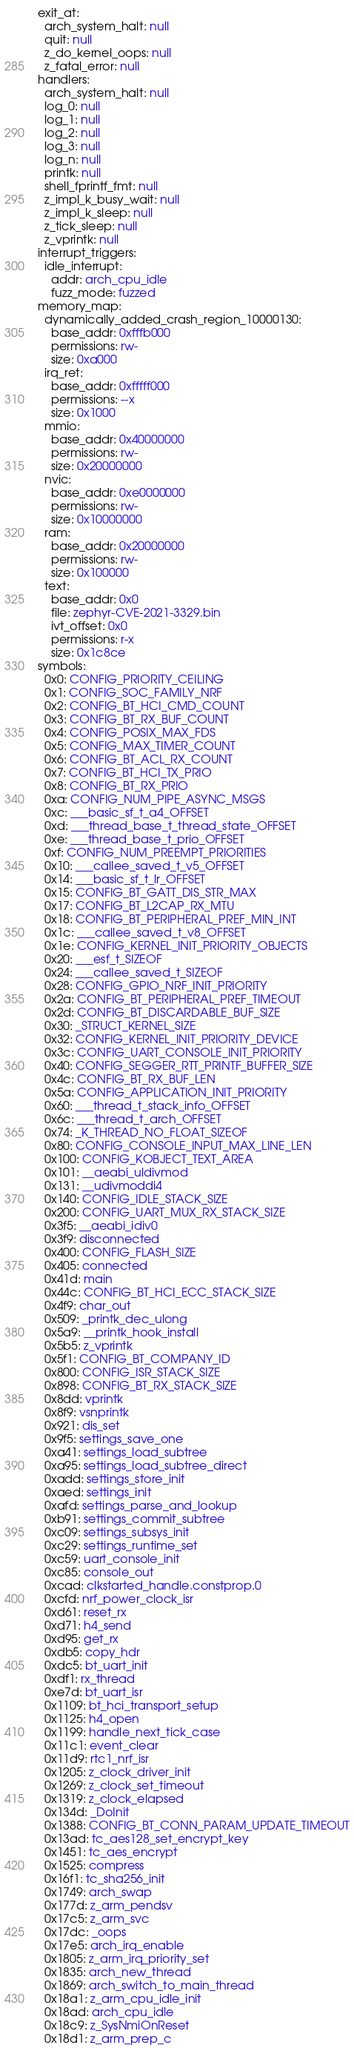<code> <loc_0><loc_0><loc_500><loc_500><_YAML_>exit_at:
  arch_system_halt: null
  quit: null
  z_do_kernel_oops: null
  z_fatal_error: null
handlers:
  arch_system_halt: null
  log_0: null
  log_1: null
  log_2: null
  log_3: null
  log_n: null
  printk: null
  shell_fprintf_fmt: null
  z_impl_k_busy_wait: null
  z_impl_k_sleep: null
  z_tick_sleep: null
  z_vprintk: null
interrupt_triggers:
  idle_interrupt:
    addr: arch_cpu_idle
    fuzz_mode: fuzzed
memory_map:
  dynamically_added_crash_region_10000130:
    base_addr: 0xfffb000
    permissions: rw-
    size: 0xa000
  irq_ret:
    base_addr: 0xfffff000
    permissions: --x
    size: 0x1000
  mmio:
    base_addr: 0x40000000
    permissions: rw-
    size: 0x20000000
  nvic:
    base_addr: 0xe0000000
    permissions: rw-
    size: 0x10000000
  ram:
    base_addr: 0x20000000
    permissions: rw-
    size: 0x100000
  text:
    base_addr: 0x0
    file: zephyr-CVE-2021-3329.bin
    ivt_offset: 0x0
    permissions: r-x
    size: 0x1c8ce
symbols:
  0x0: CONFIG_PRIORITY_CEILING
  0x1: CONFIG_SOC_FAMILY_NRF
  0x2: CONFIG_BT_HCI_CMD_COUNT
  0x3: CONFIG_BT_RX_BUF_COUNT
  0x4: CONFIG_POSIX_MAX_FDS
  0x5: CONFIG_MAX_TIMER_COUNT
  0x6: CONFIG_BT_ACL_RX_COUNT
  0x7: CONFIG_BT_HCI_TX_PRIO
  0x8: CONFIG_BT_RX_PRIO
  0xa: CONFIG_NUM_PIPE_ASYNC_MSGS
  0xc: ___basic_sf_t_a4_OFFSET
  0xd: ___thread_base_t_thread_state_OFFSET
  0xe: ___thread_base_t_prio_OFFSET
  0xf: CONFIG_NUM_PREEMPT_PRIORITIES
  0x10: ___callee_saved_t_v5_OFFSET
  0x14: ___basic_sf_t_lr_OFFSET
  0x15: CONFIG_BT_GATT_DIS_STR_MAX
  0x17: CONFIG_BT_L2CAP_RX_MTU
  0x18: CONFIG_BT_PERIPHERAL_PREF_MIN_INT
  0x1c: ___callee_saved_t_v8_OFFSET
  0x1e: CONFIG_KERNEL_INIT_PRIORITY_OBJECTS
  0x20: ___esf_t_SIZEOF
  0x24: ___callee_saved_t_SIZEOF
  0x28: CONFIG_GPIO_NRF_INIT_PRIORITY
  0x2a: CONFIG_BT_PERIPHERAL_PREF_TIMEOUT
  0x2d: CONFIG_BT_DISCARDABLE_BUF_SIZE
  0x30: _STRUCT_KERNEL_SIZE
  0x32: CONFIG_KERNEL_INIT_PRIORITY_DEVICE
  0x3c: CONFIG_UART_CONSOLE_INIT_PRIORITY
  0x40: CONFIG_SEGGER_RTT_PRINTF_BUFFER_SIZE
  0x4c: CONFIG_BT_RX_BUF_LEN
  0x5a: CONFIG_APPLICATION_INIT_PRIORITY
  0x60: ___thread_t_stack_info_OFFSET
  0x6c: ___thread_t_arch_OFFSET
  0x74: _K_THREAD_NO_FLOAT_SIZEOF
  0x80: CONFIG_CONSOLE_INPUT_MAX_LINE_LEN
  0x100: CONFIG_KOBJECT_TEXT_AREA
  0x101: __aeabi_uldivmod
  0x131: __udivmoddi4
  0x140: CONFIG_IDLE_STACK_SIZE
  0x200: CONFIG_UART_MUX_RX_STACK_SIZE
  0x3f5: __aeabi_idiv0
  0x3f9: disconnected
  0x400: CONFIG_FLASH_SIZE
  0x405: connected
  0x41d: main
  0x44c: CONFIG_BT_HCI_ECC_STACK_SIZE
  0x4f9: char_out
  0x509: _printk_dec_ulong
  0x5a9: __printk_hook_install
  0x5b5: z_vprintk
  0x5f1: CONFIG_BT_COMPANY_ID
  0x800: CONFIG_ISR_STACK_SIZE
  0x898: CONFIG_BT_RX_STACK_SIZE
  0x8dd: vprintk
  0x8f9: vsnprintk
  0x921: dis_set
  0x9f5: settings_save_one
  0xa41: settings_load_subtree
  0xa95: settings_load_subtree_direct
  0xadd: settings_store_init
  0xaed: settings_init
  0xafd: settings_parse_and_lookup
  0xb91: settings_commit_subtree
  0xc09: settings_subsys_init
  0xc29: settings_runtime_set
  0xc59: uart_console_init
  0xc85: console_out
  0xcad: clkstarted_handle.constprop.0
  0xcfd: nrf_power_clock_isr
  0xd61: reset_rx
  0xd71: h4_send
  0xd95: get_rx
  0xdb5: copy_hdr
  0xdc5: bt_uart_init
  0xdf1: rx_thread
  0xe7d: bt_uart_isr
  0x1109: bt_hci_transport_setup
  0x1125: h4_open
  0x1199: handle_next_tick_case
  0x11c1: event_clear
  0x11d9: rtc1_nrf_isr
  0x1205: z_clock_driver_init
  0x1269: z_clock_set_timeout
  0x1319: z_clock_elapsed
  0x134d: _DoInit
  0x1388: CONFIG_BT_CONN_PARAM_UPDATE_TIMEOUT
  0x13ad: tc_aes128_set_encrypt_key
  0x1451: tc_aes_encrypt
  0x1525: compress
  0x16f1: tc_sha256_init
  0x1749: arch_swap
  0x177d: z_arm_pendsv
  0x17c5: z_arm_svc
  0x17dc: _oops
  0x17e5: arch_irq_enable
  0x1805: z_arm_irq_priority_set
  0x1835: arch_new_thread
  0x1869: arch_switch_to_main_thread
  0x18a1: z_arm_cpu_idle_init
  0x18ad: arch_cpu_idle
  0x18c9: z_SysNmiOnReset
  0x18d1: z_arm_prep_c</code> 